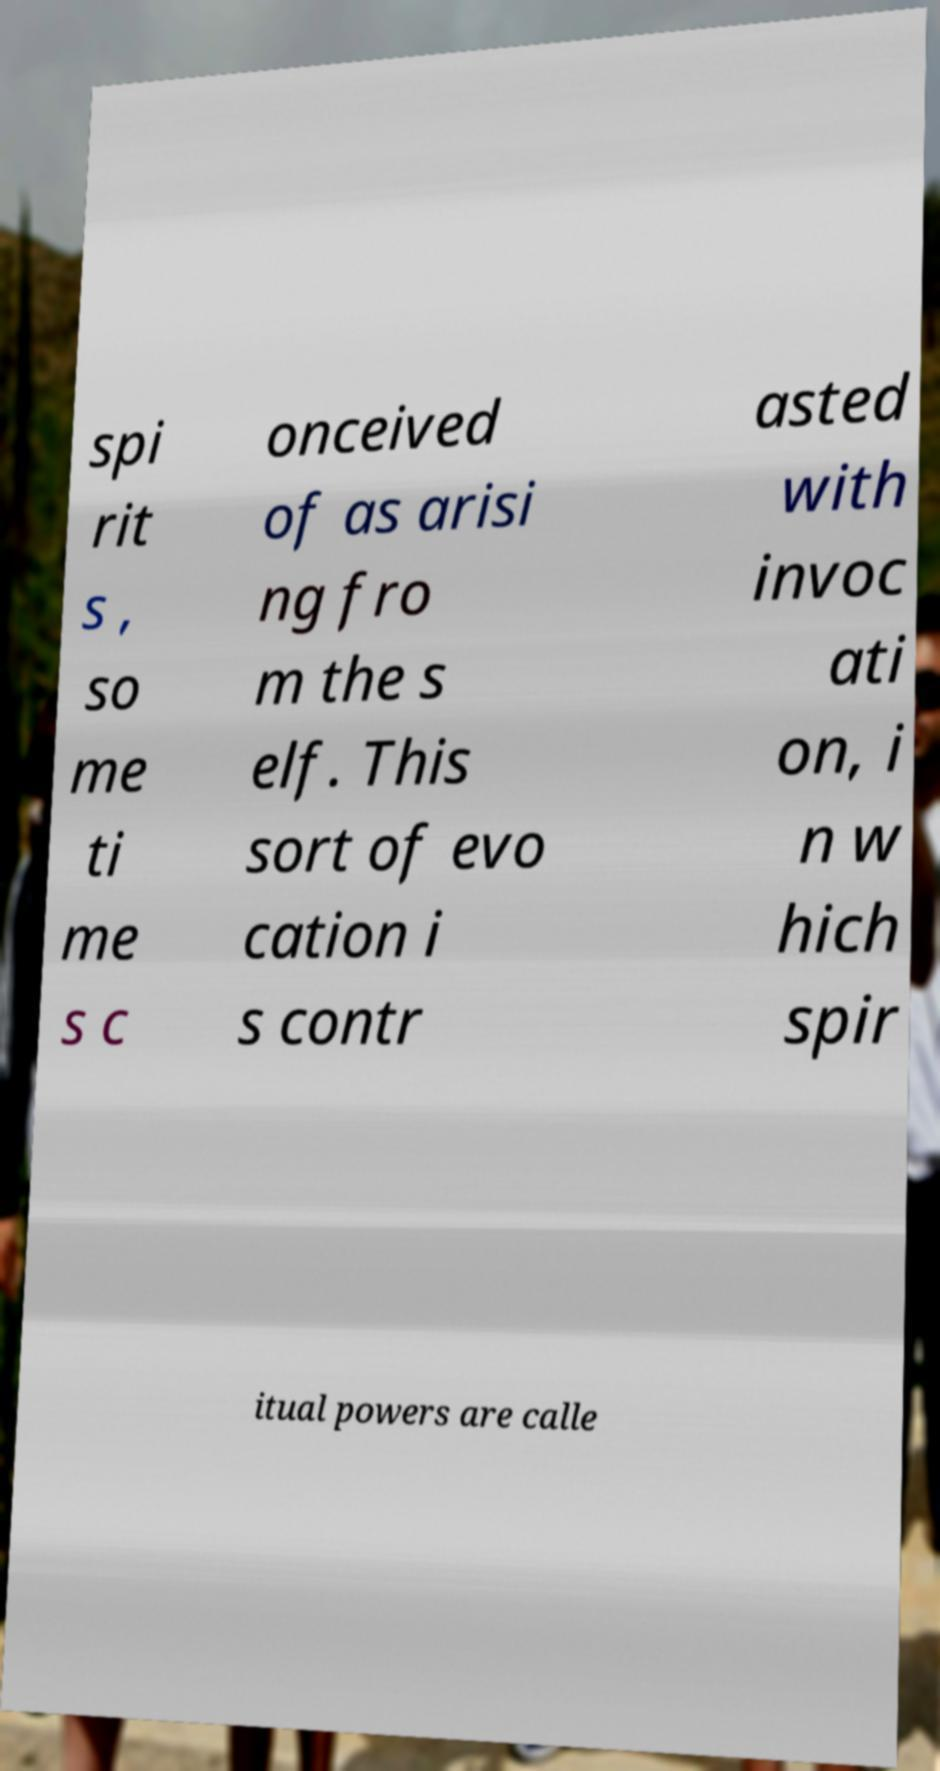Please read and relay the text visible in this image. What does it say? spi rit s , so me ti me s c onceived of as arisi ng fro m the s elf. This sort of evo cation i s contr asted with invoc ati on, i n w hich spir itual powers are calle 